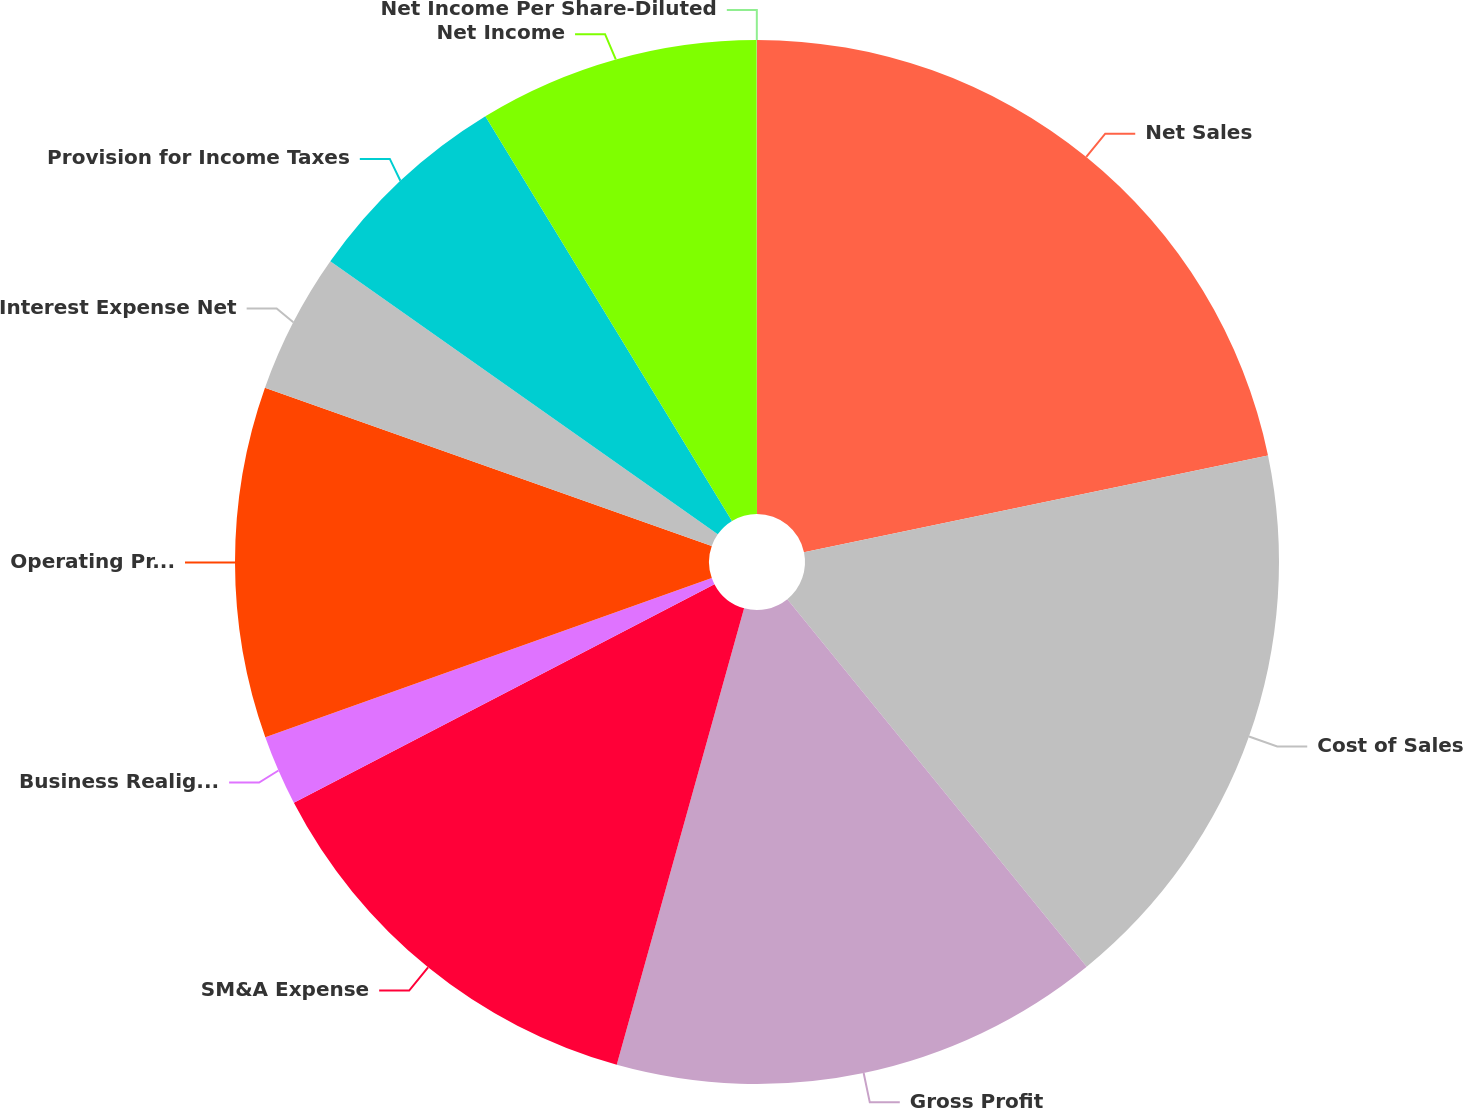Convert chart to OTSL. <chart><loc_0><loc_0><loc_500><loc_500><pie_chart><fcel>Net Sales<fcel>Cost of Sales<fcel>Gross Profit<fcel>SM&A Expense<fcel>Business Realignment Charges<fcel>Operating Profit<fcel>Interest Expense Net<fcel>Provision for Income Taxes<fcel>Net Income<fcel>Net Income Per Share-Diluted<nl><fcel>21.73%<fcel>17.39%<fcel>15.21%<fcel>13.04%<fcel>2.18%<fcel>10.87%<fcel>4.35%<fcel>6.52%<fcel>8.7%<fcel>0.01%<nl></chart> 